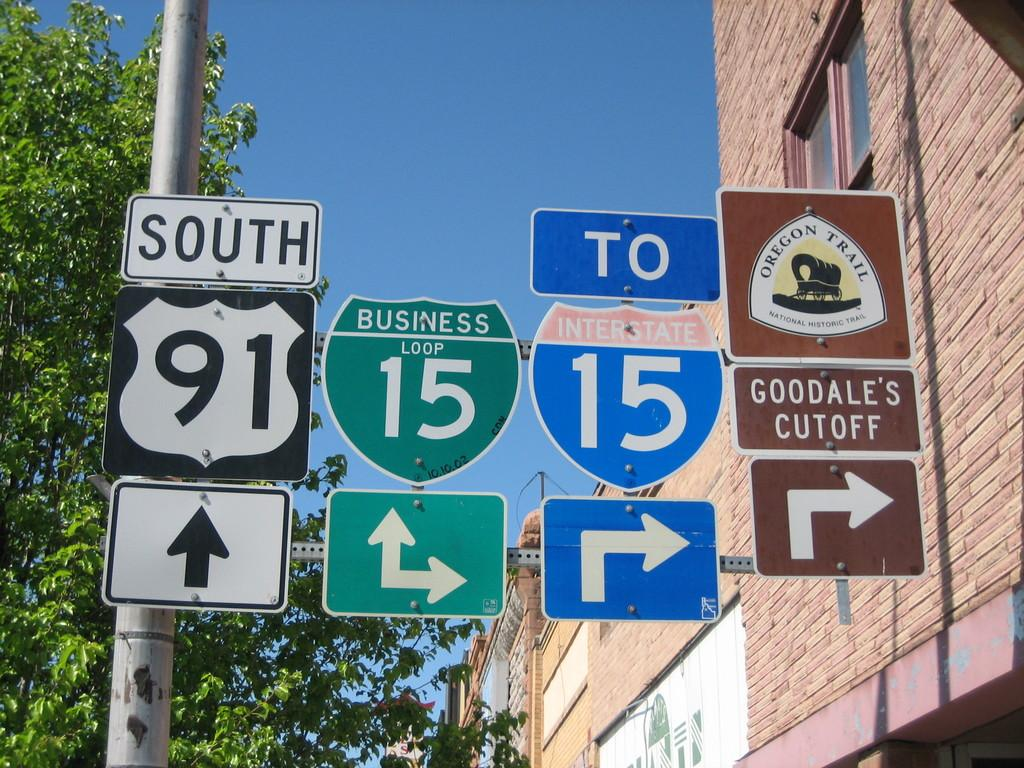<image>
Relay a brief, clear account of the picture shown. some signs with two of them having the numbers 15 on them 